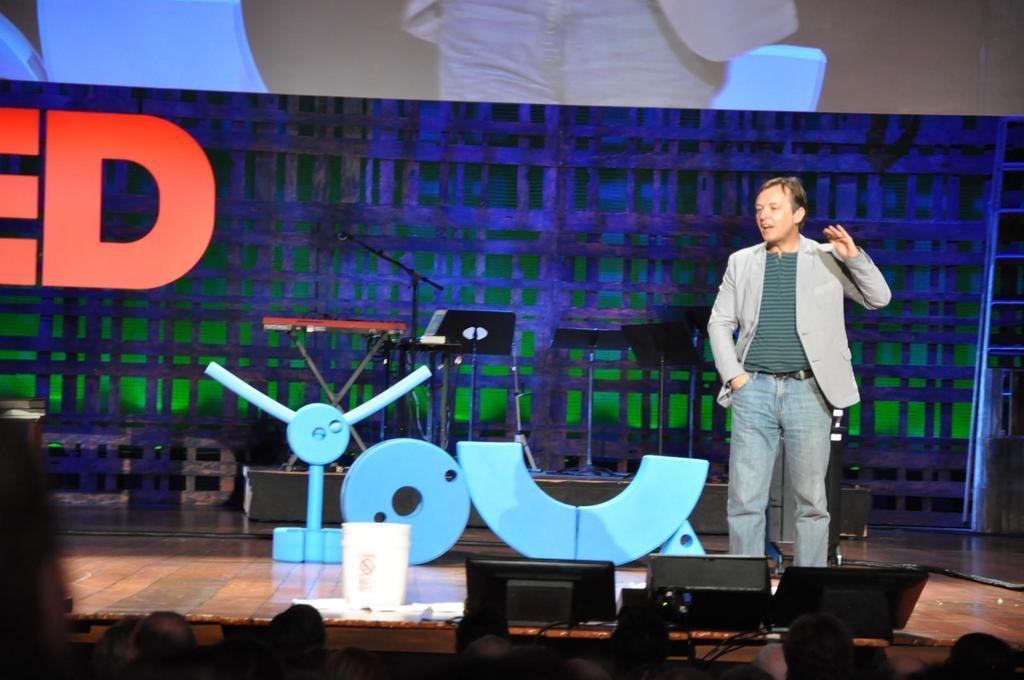Please provide a concise description of this image. This picture shows a man standing and speaking and we see a projector screen and few musical instruments on the Dais and few audience seated. 